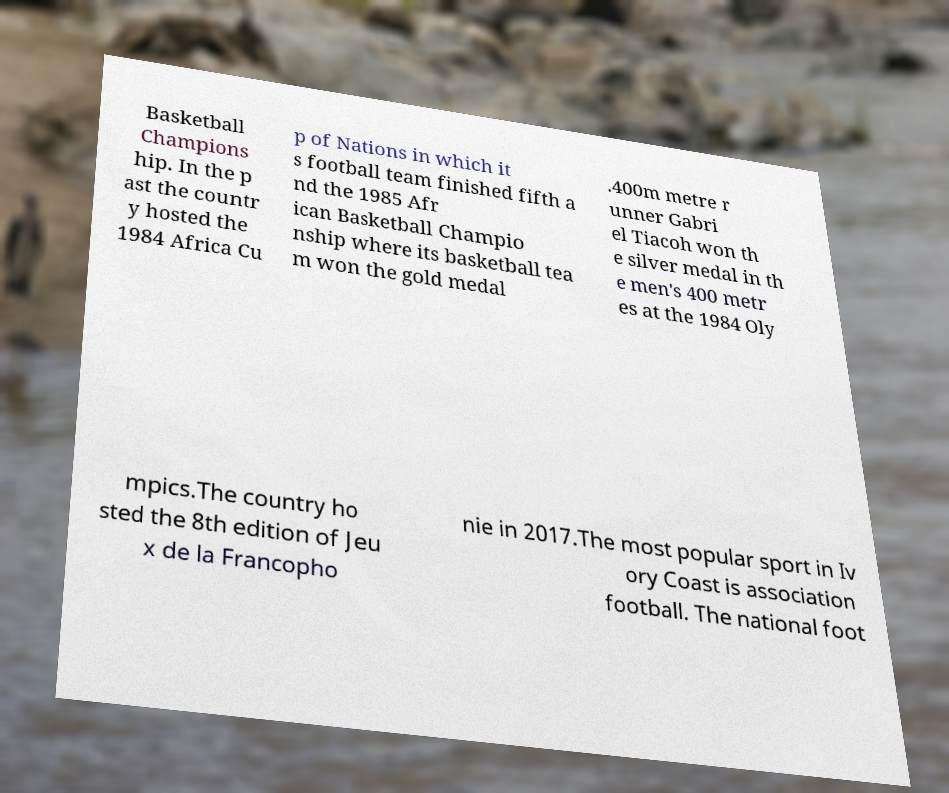Could you extract and type out the text from this image? Basketball Champions hip. In the p ast the countr y hosted the 1984 Africa Cu p of Nations in which it s football team finished fifth a nd the 1985 Afr ican Basketball Champio nship where its basketball tea m won the gold medal .400m metre r unner Gabri el Tiacoh won th e silver medal in th e men's 400 metr es at the 1984 Oly mpics.The country ho sted the 8th edition of Jeu x de la Francopho nie in 2017.The most popular sport in Iv ory Coast is association football. The national foot 